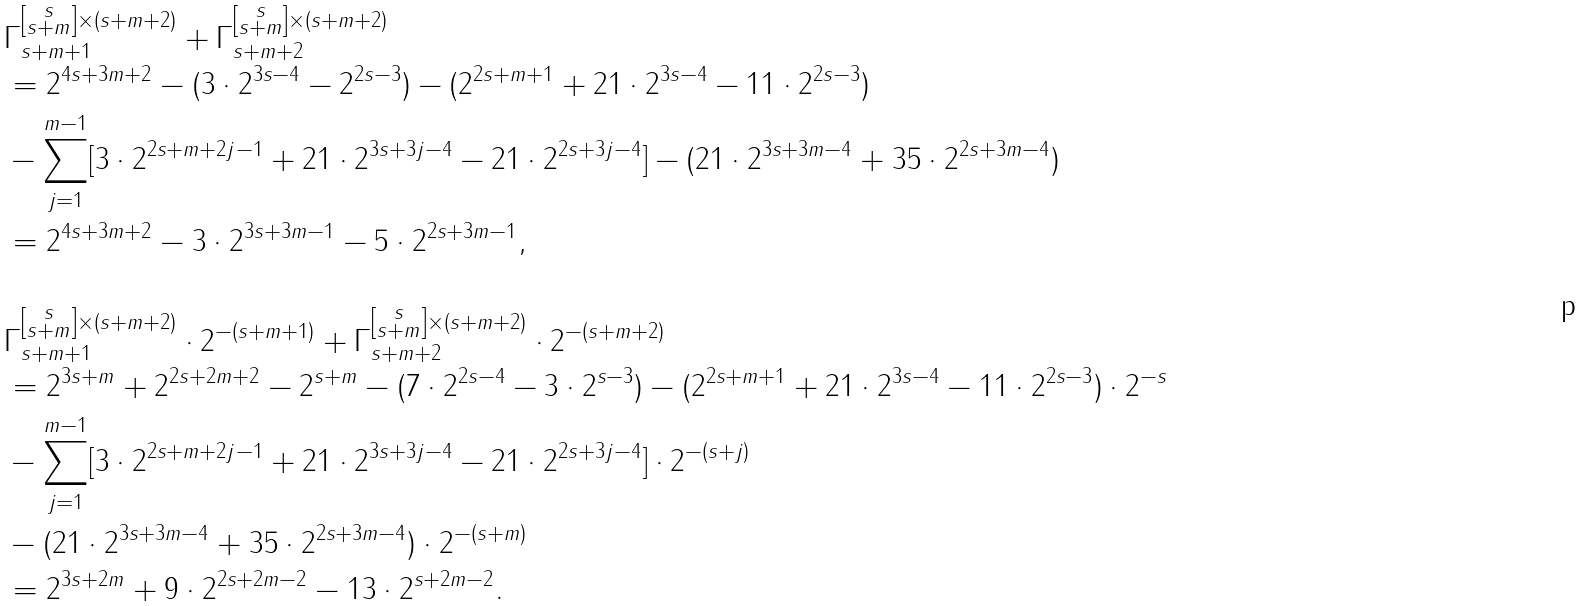Convert formula to latex. <formula><loc_0><loc_0><loc_500><loc_500>& \Gamma _ { s + m + 1 } ^ { \left [ \substack { s \\ s + m } \right ] \times ( s + m + 2 ) } + \Gamma _ { s + m + 2 } ^ { \left [ \substack { s \\ s + m } \right ] \times ( s + m + 2 ) } \\ & = 2 ^ { 4 s + 3 m + 2 } - ( 3 \cdot 2 ^ { 3 s - 4 } - 2 ^ { 2 s - 3 } ) - ( 2 ^ { 2 s + m + 1 } + 2 1 \cdot 2 ^ { 3 s - 4 } - 1 1 \cdot 2 ^ { 2 s - 3 } ) \\ & - \sum _ { j = 1 } ^ { m - 1 } [ 3 \cdot 2 ^ { 2 s + m + 2 j - 1 } + 2 1 \cdot 2 ^ { 3 s + 3 j - 4 } - 2 1 \cdot 2 ^ { 2 s + 3 j - 4 } ] - ( 2 1 \cdot 2 ^ { 3 s + 3 m - 4 } + 3 5 \cdot 2 ^ { 2 s + 3 m - 4 } ) \\ & = 2 ^ { 4 s + 3 m + 2 } - 3 \cdot 2 ^ { 3 s + 3 m - 1 } - 5 \cdot 2 ^ { 2 s + 3 m - 1 } , \\ & \\ & \Gamma _ { s + m + 1 } ^ { \left [ \substack { s \\ s + m } \right ] \times ( s + m + 2 ) } \cdot 2 ^ { - ( s + m + 1 ) } + \Gamma _ { s + m + 2 } ^ { \left [ \substack { s \\ s + m } \right ] \times ( s + m + 2 ) } \cdot 2 ^ { - ( s + m + 2 ) } \\ & = 2 ^ { 3 s + m } + 2 ^ { 2 s + 2 m + 2 } - 2 ^ { s + m } - ( 7 \cdot 2 ^ { 2 s - 4 } - 3 \cdot 2 ^ { s - 3 } ) - ( 2 ^ { 2 s + m + 1 } + 2 1 \cdot 2 ^ { 3 s - 4 } - 1 1 \cdot 2 ^ { 2 s - 3 } ) \cdot 2 ^ { - s } \\ & - \sum _ { j = 1 } ^ { m - 1 } [ 3 \cdot 2 ^ { 2 s + m + 2 j - 1 } + 2 1 \cdot 2 ^ { 3 s + 3 j - 4 } - 2 1 \cdot 2 ^ { 2 s + 3 j - 4 } ] \cdot 2 ^ { - ( s + j ) } \\ & - ( 2 1 \cdot 2 ^ { 3 s + 3 m - 4 } + 3 5 \cdot 2 ^ { 2 s + 3 m - 4 } ) \cdot 2 ^ { - ( s + m ) } \\ & = 2 ^ { 3 s + 2 m } + 9 \cdot 2 ^ { 2 s + 2 m - 2 } - 1 3 \cdot 2 ^ { s + 2 m - 2 } .</formula> 